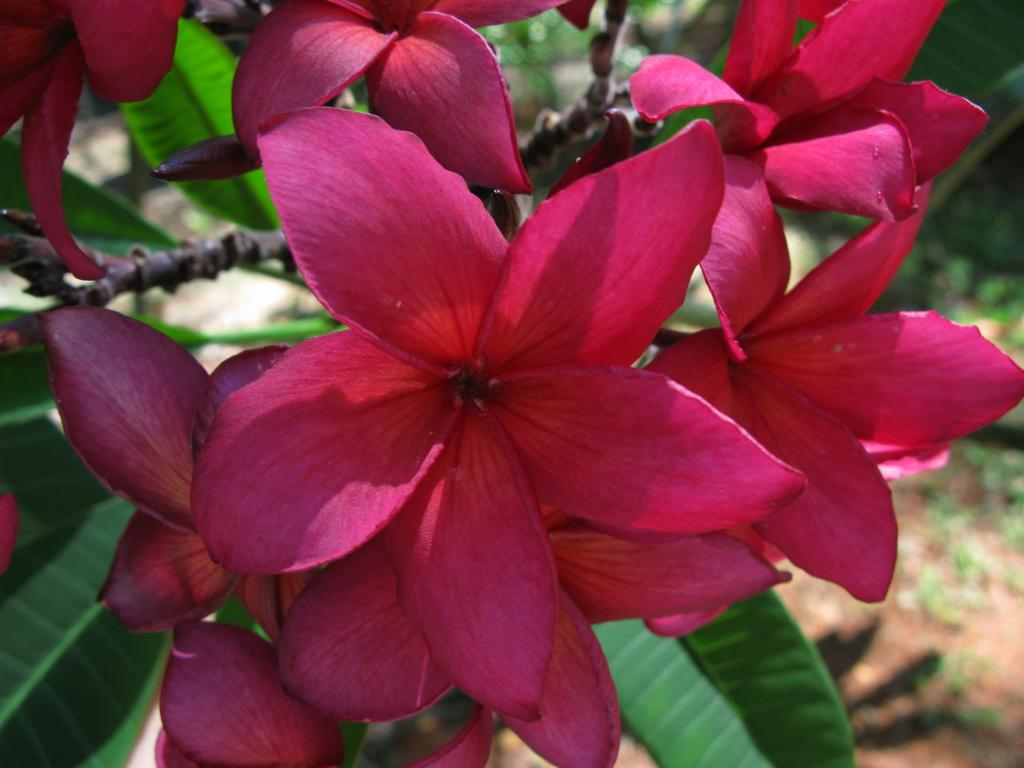What type of flowers can be seen in the image? There are pink color flowers in the image. What else can be seen in the image besides the flowers? Leaves of trees are visible in the image. What type of cap is the eye wearing in the image? There is no cap or eye present in the image; it only features pink color flowers and leaves of trees. 